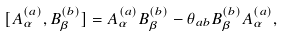Convert formula to latex. <formula><loc_0><loc_0><loc_500><loc_500>[ A ^ { ( a ) } _ { \alpha } , B ^ { ( b ) } _ { \beta } ] = A ^ { ( a ) } _ { \alpha } B ^ { ( b ) } _ { \beta } - \theta _ { a b } B ^ { ( b ) } _ { \beta } A ^ { ( a ) } _ { \alpha } ,</formula> 